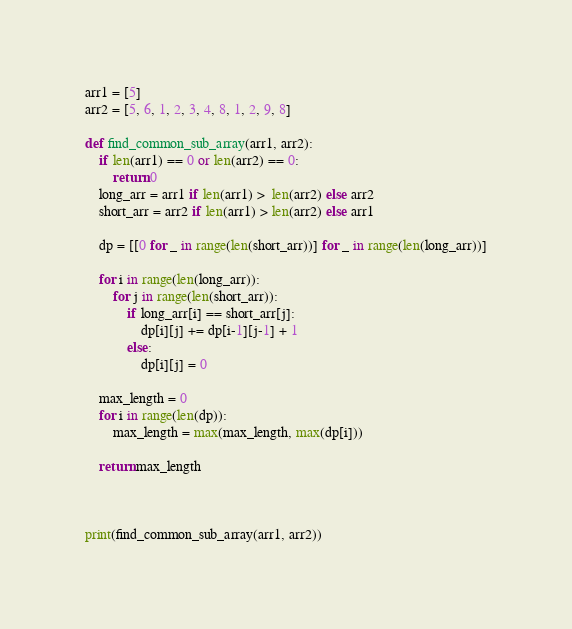<code> <loc_0><loc_0><loc_500><loc_500><_Python_>
arr1 = [5]
arr2 = [5, 6, 1, 2, 3, 4, 8, 1, 2, 9, 8]

def find_common_sub_array(arr1, arr2):
    if len(arr1) == 0 or len(arr2) == 0:
        return 0
    long_arr = arr1 if len(arr1) >  len(arr2) else arr2
    short_arr = arr2 if len(arr1) > len(arr2) else arr1
    
    dp = [[0 for _ in range(len(short_arr))] for _ in range(len(long_arr))]
    
    for i in range(len(long_arr)):
        for j in range(len(short_arr)):
            if long_arr[i] == short_arr[j]:
                dp[i][j] += dp[i-1][j-1] + 1
            else:
                dp[i][j] = 0

    max_length = 0
    for i in range(len(dp)):
        max_length = max(max_length, max(dp[i]))
    
    return max_length



print(find_common_sub_array(arr1, arr2))</code> 